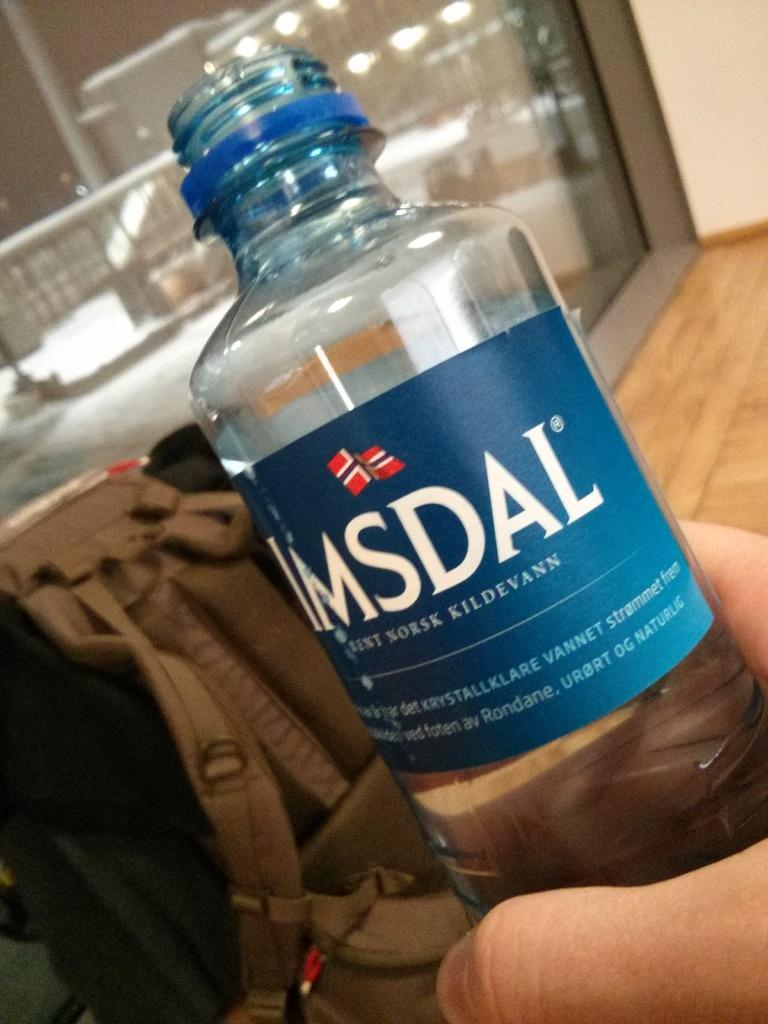What object is being held by someone in the image? There is a bottle in the image, and someone is holding it. What else can be seen in the image besides the bottle? There is a backpack visible in the image. What type of architectural feature is present in the image? There is a glass wall in the image. What type of furniture is being used for growth in the image? There is no furniture or growth present in the image; it only features a bottle, a backpack, and a glass wall. 